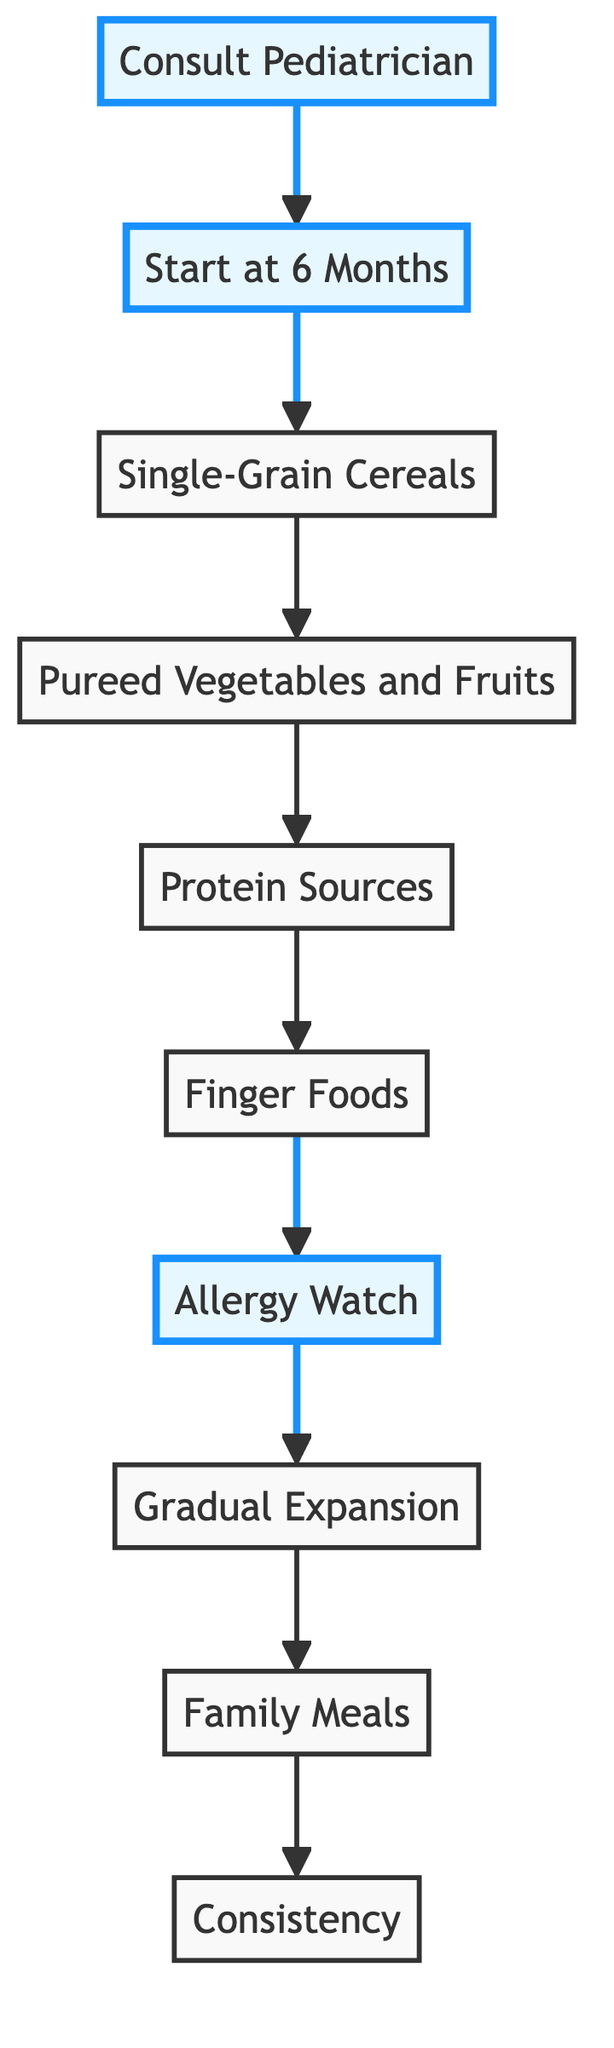What is the first step in the diagram? The first step in the diagram is identified as "Consult Pediatrician," which indicates that checking with a child's doctor is the initial action before introducing solid foods.
Answer: Consult Pediatrician At what age should solid foods be introduced? The diagram specifies that solid foods should be introduced at around "6 Months," indicating the appropriate age for starting solids when the baby shows readiness.
Answer: 6 Months What type of food is introduced after single-grain cereals? After "Single-Grain Cereals," the next type of food introduced is "Pureed Vegetables and Fruits," indicating the sequence in the feeding process.
Answer: Pureed Vegetables and Fruits Which step involves monitoring for allergic reactions? The step that involves monitoring for allergic reactions follows after introducing various foods and is labeled "Allergy Watch," highlighting the importance of observing potential allergies.
Answer: Allergy Watch How many steps are there in the diagram? By counting the steps in the diagram from "Consult Pediatrician" to "Consistency," there are a total of 10 distinct steps outlined in the flow chart.
Answer: 10 What is the final step in the guideline of introducing solid foods? The final step in the guideline, as shown in the diagram, is "Consistency," emphasizing the need for a stable feeding schedule along with solid foods.
Answer: Consistency What is the approximate age for introducing finger foods? According to the diagram, "Finger Foods" should be introduced at around "8 months," indicating the timing for this type of food.
Answer: 8 months What food types are included in the protein sources step? The "Protein Sources" step includes pureed or finely shredded meats, tofu, and cooked legumes, showing the variety of protein options for the baby.
Answer: Pureed or finely shredded meats, tofu, and cooked legumes What is the purpose of the "Gradual Expansion" step? The "Gradual Expansion" step aims to offer a variety of textures and flavors, helping to develop the baby's palate while avoiding specific foods until after certain ages.
Answer: Develop your baby's palate 